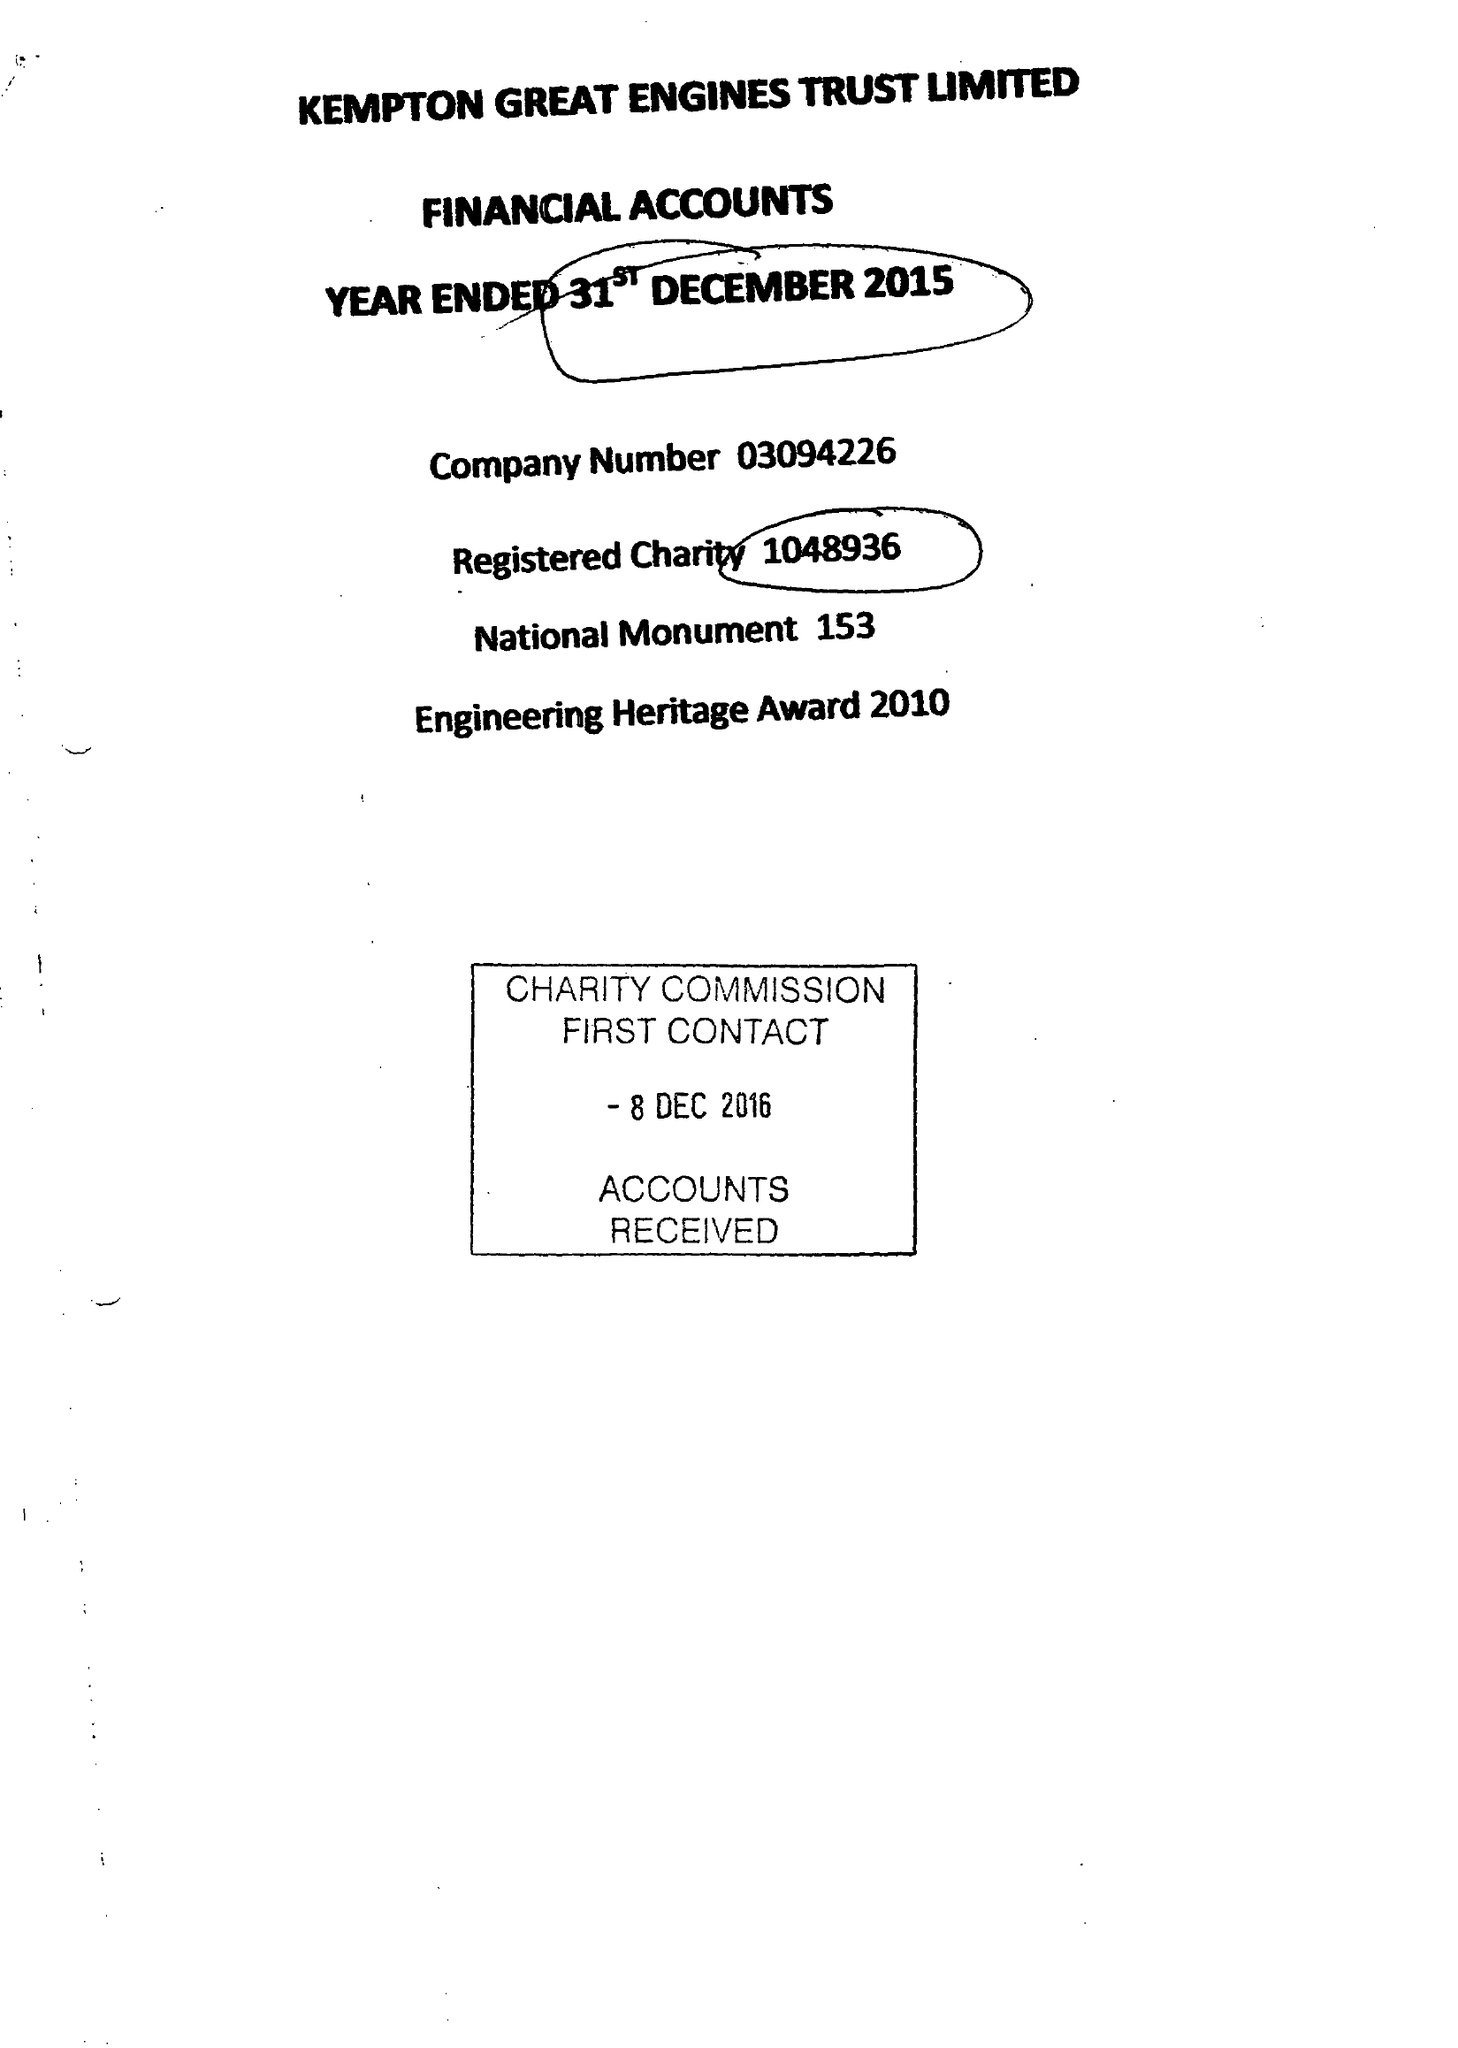What is the value for the charity_number?
Answer the question using a single word or phrase. 1048936 